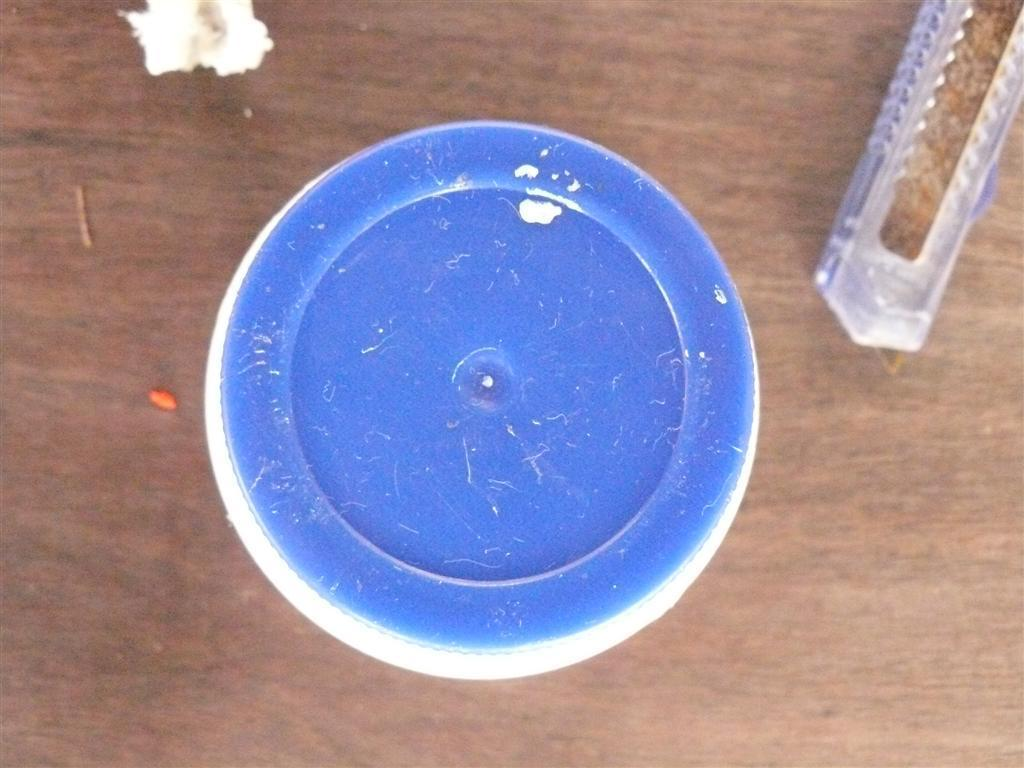How many objects are visible in the image? There are three objects in the image. What is the surface on which the objects are placed? The objects are on a wooden surface. What type of books can be seen on the wooden surface in the image? There are no books present in the image; only three objects are visible on the wooden surface. Is there any coal visible on the wooden surface in the image? There is no coal present in the image; only three objects are visible on the wooden surface. 